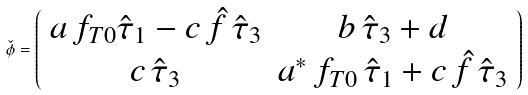Convert formula to latex. <formula><loc_0><loc_0><loc_500><loc_500>\check { \phi } = \left ( \begin{array} { c c } a \, f _ { T 0 } \hat { \tau } _ { 1 } - c \, \hat { f } \, \hat { \tau } _ { 3 } & b \, \hat { \tau } _ { 3 } + d \\ c \, \hat { \tau } _ { 3 } & a ^ { * } \, f _ { T 0 } \, \hat { \tau } _ { 1 } + c \, \hat { f } \, \hat { \tau } _ { 3 } \\ \end{array} \right )</formula> 